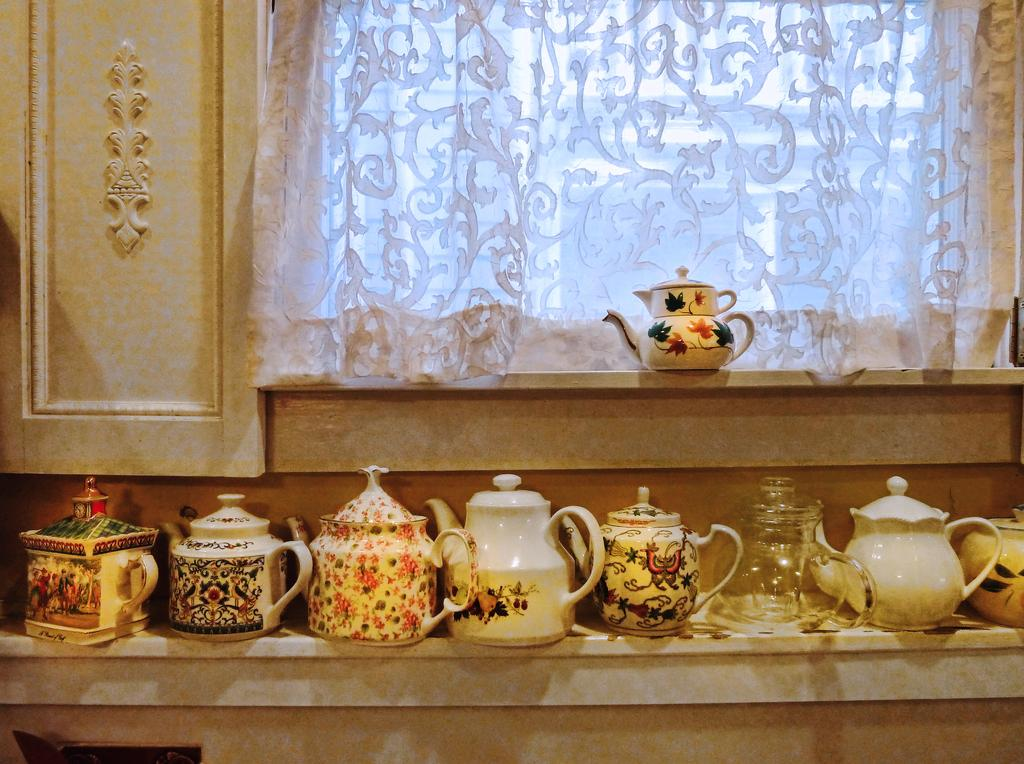What type of containers are present in the image? There are kettle jars in the image. What can be seen in the background of the image? There is a window in the image. Is there any window treatment present in the image? Yes, there is a curtain associated with the window. What type of flesh can be seen in the image? There is no flesh present in the image; it features kettle jars, a window, and a curtain. What book is the person reading in the image? There is no person reading a book in the image. 